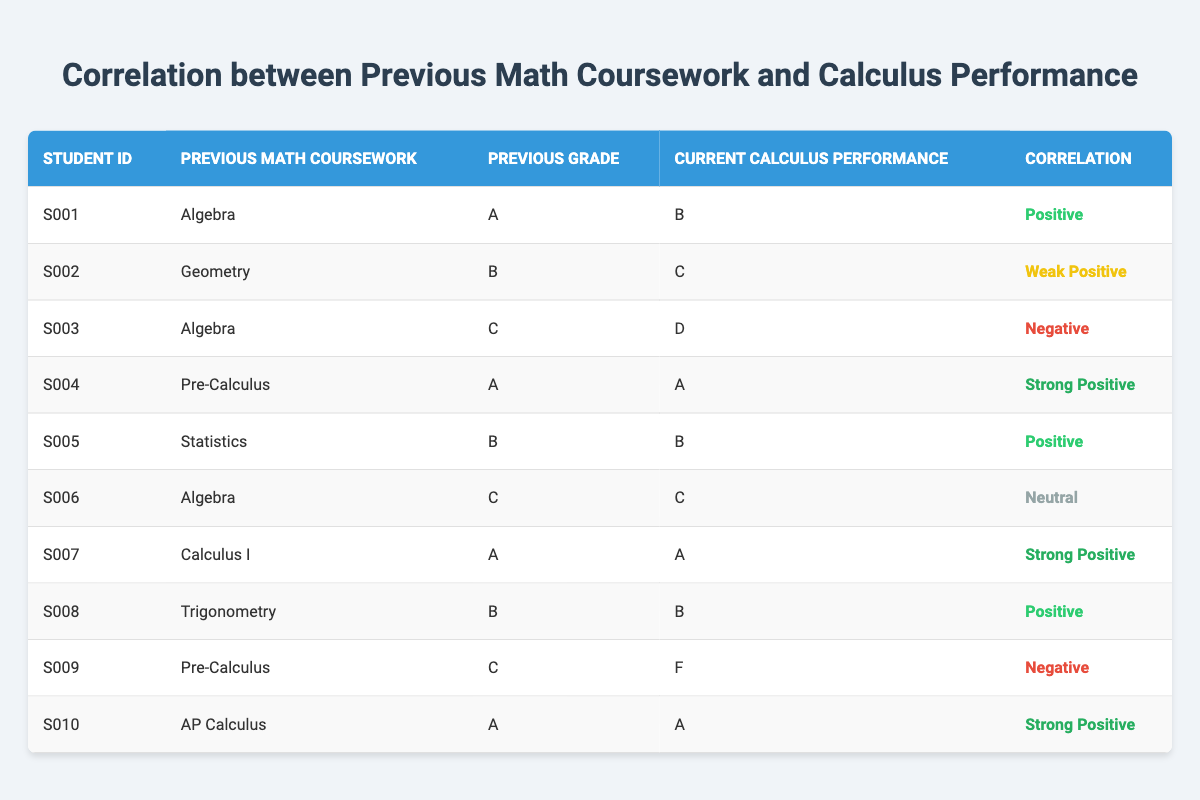What is the correlation for Student S007? In the table, locate Student S007 and check the corresponding Correlation column. For S007, the Correlation is marked as "Strong Positive".
Answer: Strong Positive How many students with a previous grade of "C" received a current calculus performance grade of "C"? Look for all entries where the Previous Grade is "C" and then check the Current Calculus Performance for those students. There is one student (S006) who fits this criteria.
Answer: 1 Is there any student that had a previous grade of "B" and ended up with a current calculus performance of "F"? Scan the table for any student with a Previous Grade of "B" and observe their Current Calculus Performance. There are no students who have both conditions, confirming the answer is false.
Answer: No What is the average previous grade of students with a strong positive correlation? Identify the students with a strong positive correlation: S004, S007, and S010. Their previous grades are A, A, and A. To find the average, calculate (A + A + A) and divide by 3 since all grades are the same.
Answer: A Which previous math coursework had the highest correlation with current calculus performance? Review the Correlation column values: "Strong Positive" has three instances (S004, S007, S010). All three correspond to different previous coursework: Pre-Calculus, Calculus I, and AP Calculus. There is no single answer, so it can be stated that "Strong Positive" is the highest with multiple coursework types.
Answer: Strong Positive (Pre-Calculus, AP Calculus, Calculus I) 